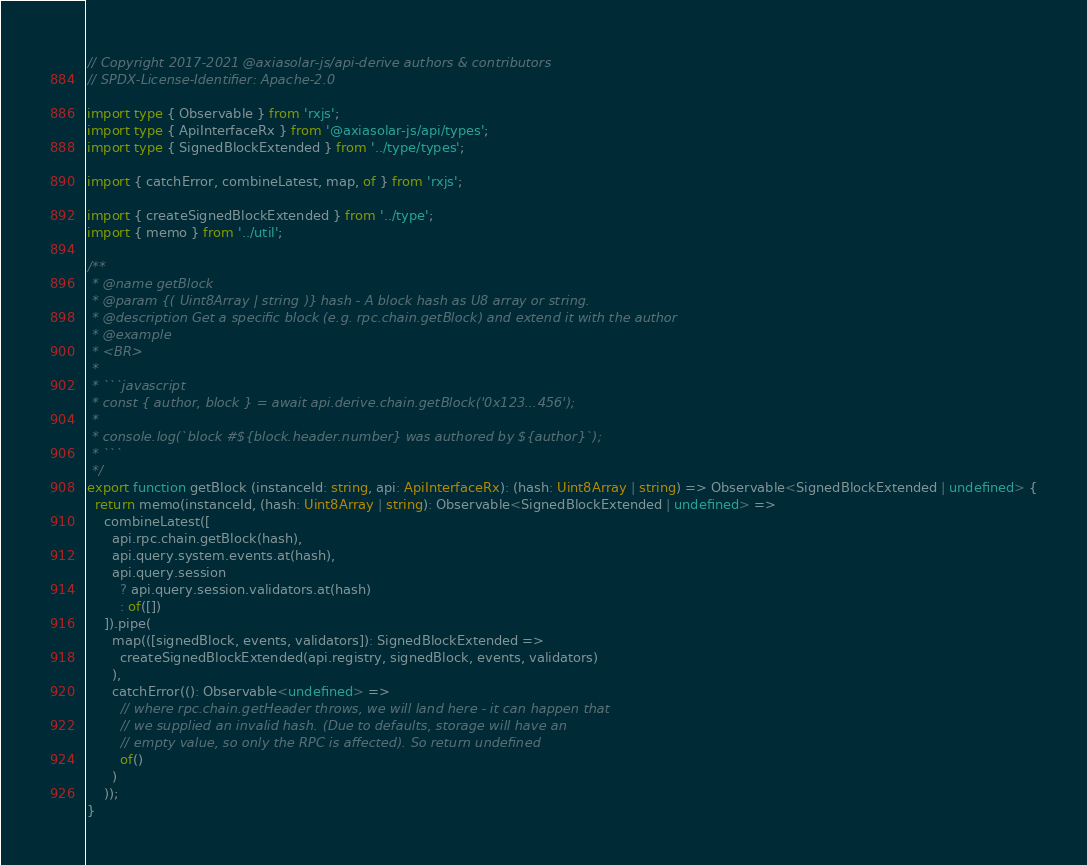Convert code to text. <code><loc_0><loc_0><loc_500><loc_500><_TypeScript_>// Copyright 2017-2021 @axiasolar-js/api-derive authors & contributors
// SPDX-License-Identifier: Apache-2.0

import type { Observable } from 'rxjs';
import type { ApiInterfaceRx } from '@axiasolar-js/api/types';
import type { SignedBlockExtended } from '../type/types';

import { catchError, combineLatest, map, of } from 'rxjs';

import { createSignedBlockExtended } from '../type';
import { memo } from '../util';

/**
 * @name getBlock
 * @param {( Uint8Array | string )} hash - A block hash as U8 array or string.
 * @description Get a specific block (e.g. rpc.chain.getBlock) and extend it with the author
 * @example
 * <BR>
 *
 * ```javascript
 * const { author, block } = await api.derive.chain.getBlock('0x123...456');
 *
 * console.log(`block #${block.header.number} was authored by ${author}`);
 * ```
 */
export function getBlock (instanceId: string, api: ApiInterfaceRx): (hash: Uint8Array | string) => Observable<SignedBlockExtended | undefined> {
  return memo(instanceId, (hash: Uint8Array | string): Observable<SignedBlockExtended | undefined> =>
    combineLatest([
      api.rpc.chain.getBlock(hash),
      api.query.system.events.at(hash),
      api.query.session
        ? api.query.session.validators.at(hash)
        : of([])
    ]).pipe(
      map(([signedBlock, events, validators]): SignedBlockExtended =>
        createSignedBlockExtended(api.registry, signedBlock, events, validators)
      ),
      catchError((): Observable<undefined> =>
        // where rpc.chain.getHeader throws, we will land here - it can happen that
        // we supplied an invalid hash. (Due to defaults, storage will have an
        // empty value, so only the RPC is affected). So return undefined
        of()
      )
    ));
}
</code> 